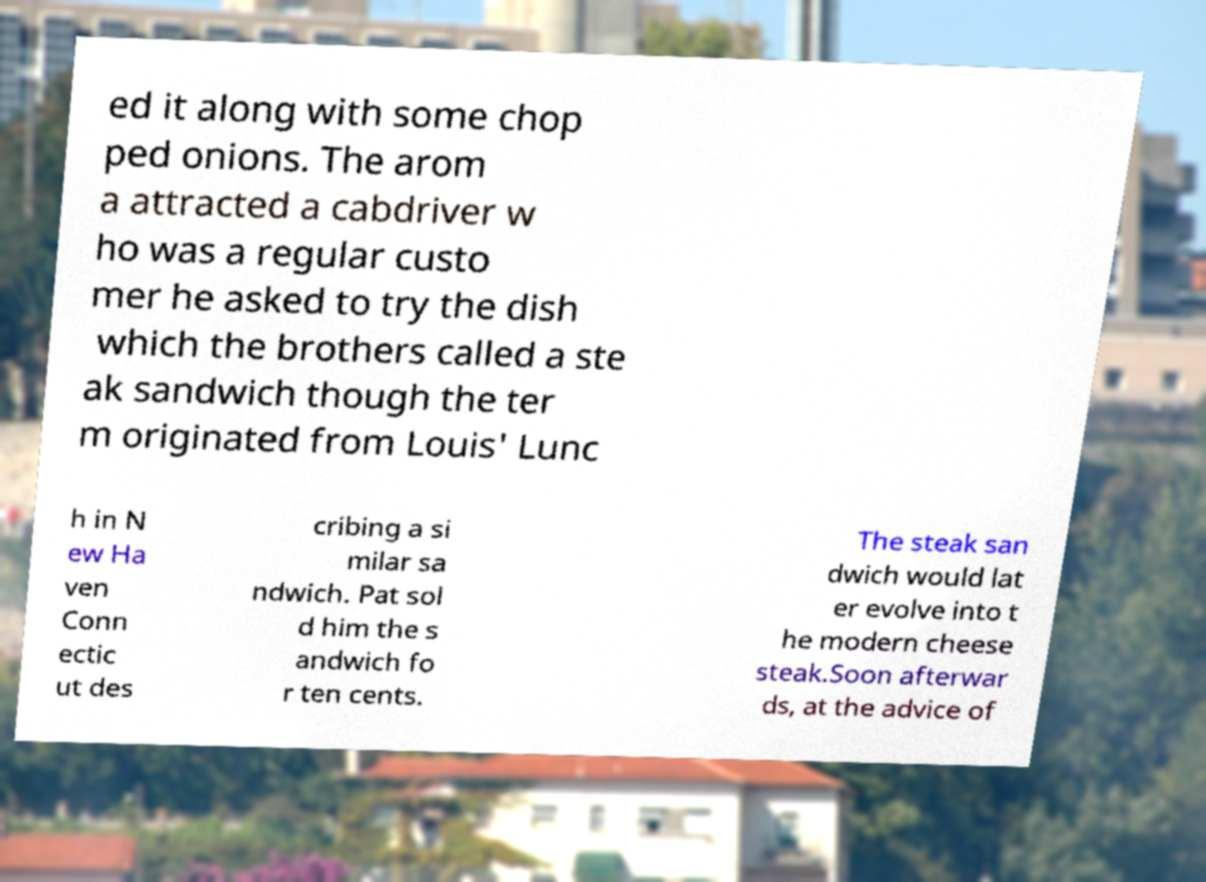Can you read and provide the text displayed in the image?This photo seems to have some interesting text. Can you extract and type it out for me? ed it along with some chop ped onions. The arom a attracted a cabdriver w ho was a regular custo mer he asked to try the dish which the brothers called a ste ak sandwich though the ter m originated from Louis' Lunc h in N ew Ha ven Conn ectic ut des cribing a si milar sa ndwich. Pat sol d him the s andwich fo r ten cents. The steak san dwich would lat er evolve into t he modern cheese steak.Soon afterwar ds, at the advice of 